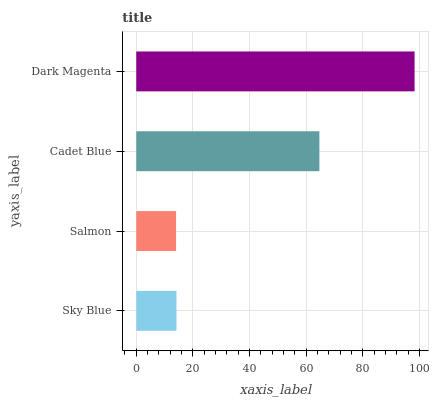Is Salmon the minimum?
Answer yes or no. Yes. Is Dark Magenta the maximum?
Answer yes or no. Yes. Is Cadet Blue the minimum?
Answer yes or no. No. Is Cadet Blue the maximum?
Answer yes or no. No. Is Cadet Blue greater than Salmon?
Answer yes or no. Yes. Is Salmon less than Cadet Blue?
Answer yes or no. Yes. Is Salmon greater than Cadet Blue?
Answer yes or no. No. Is Cadet Blue less than Salmon?
Answer yes or no. No. Is Cadet Blue the high median?
Answer yes or no. Yes. Is Sky Blue the low median?
Answer yes or no. Yes. Is Salmon the high median?
Answer yes or no. No. Is Cadet Blue the low median?
Answer yes or no. No. 